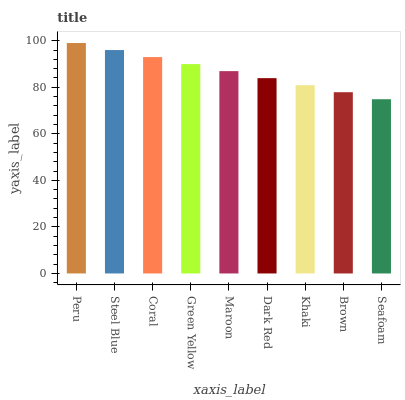Is Seafoam the minimum?
Answer yes or no. Yes. Is Peru the maximum?
Answer yes or no. Yes. Is Steel Blue the minimum?
Answer yes or no. No. Is Steel Blue the maximum?
Answer yes or no. No. Is Peru greater than Steel Blue?
Answer yes or no. Yes. Is Steel Blue less than Peru?
Answer yes or no. Yes. Is Steel Blue greater than Peru?
Answer yes or no. No. Is Peru less than Steel Blue?
Answer yes or no. No. Is Maroon the high median?
Answer yes or no. Yes. Is Maroon the low median?
Answer yes or no. Yes. Is Dark Red the high median?
Answer yes or no. No. Is Coral the low median?
Answer yes or no. No. 